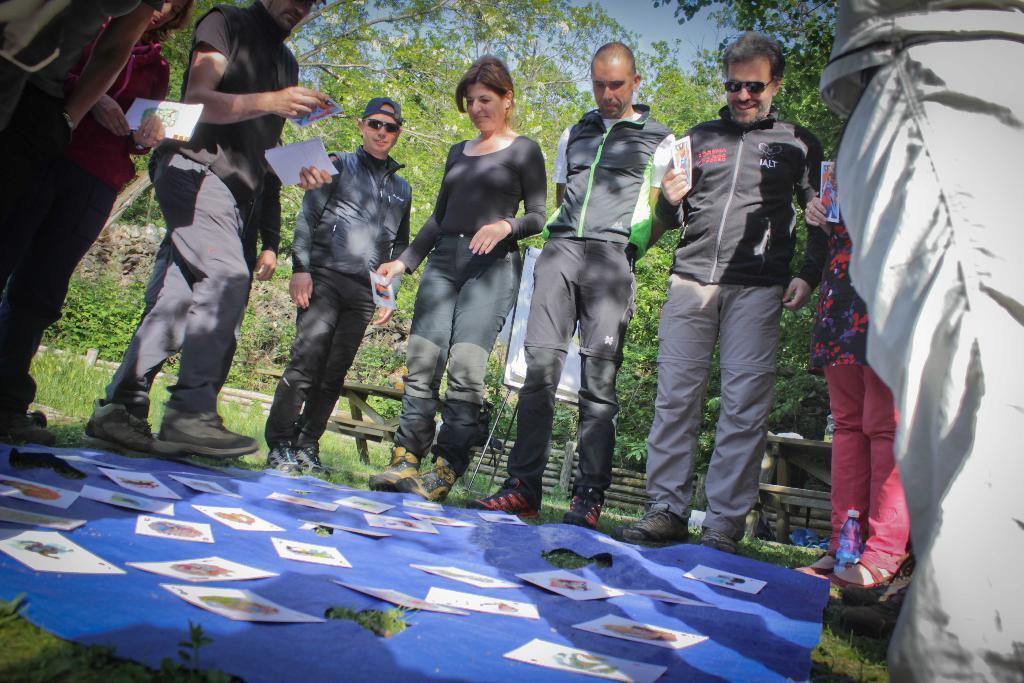Please provide a concise description of this image. In this image we can see a group of people standing on the ground holding some papers. We can also see some cards placed on a cloth kept on the ground. On the backside we can see some benches, grass, plants, a group of trees and the sky which looks cloudy. 